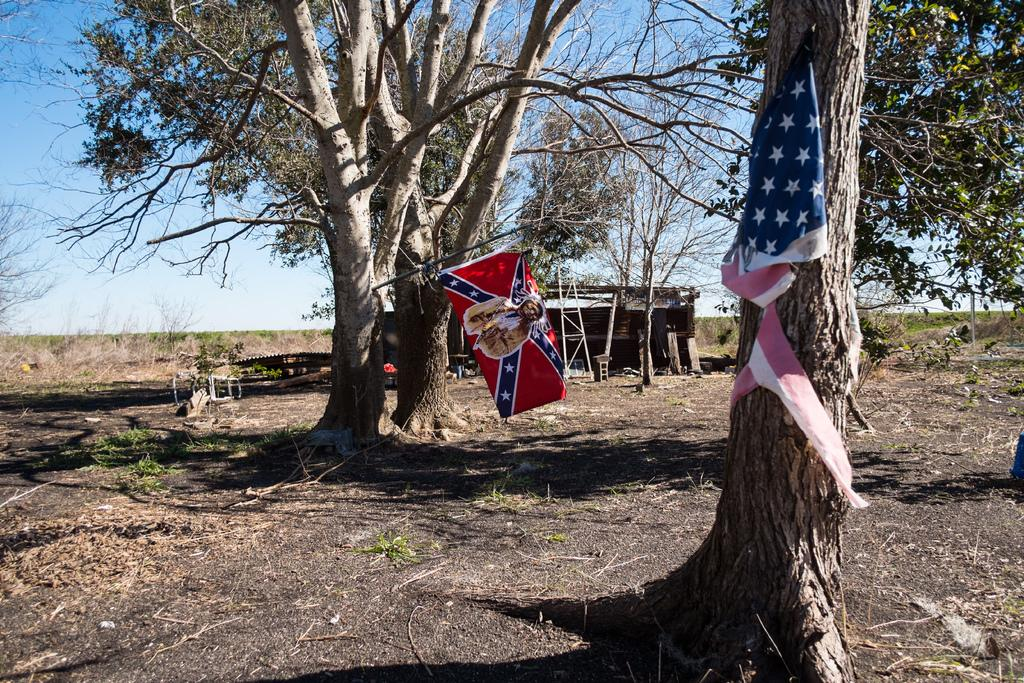What can be seen flying in the image? There are flags in the image. What type of surface is visible in the image? The ground is visible in the image. What type of vegetation is present in the image? There are trees and grass in the image. What type of structure can be seen in the image? There is a shed in the image. What else is present in the image besides the mentioned elements? There are objects in the image. What is visible in the background of the image? The sky is visible in the background of the image. What is the texture of the butter in the image? There is no butter present in the image. How does the kiss affect the flags in the image? There is no kiss present in the image, so it cannot affect the flags. 